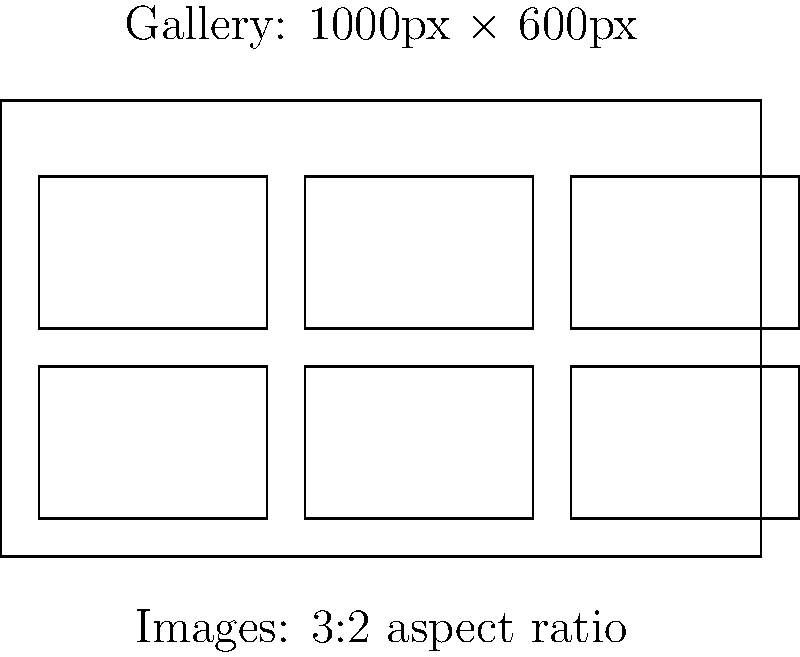As a web developer, you're tasked with creating a responsive image gallery for a client's website. The gallery container is 1000px wide and 600px tall. You need to display 6 images with a 3:2 aspect ratio, arranged in 2 rows and 3 columns, with equal spacing between images and the gallery edges. What should be the dimensions (in pixels) of each image to maximize their size while maintaining the aspect ratio and ensuring they fit within the gallery with equal spacing? To solve this problem, let's follow these steps:

1. Understand the given information:
   - Gallery size: 1000px × 600px
   - Number of images: 6 (2 rows, 3 columns)
   - Image aspect ratio: 3:2

2. Define variables:
   Let $w$ = image width, $h$ = image height, $s$ = spacing

3. Set up equations based on the gallery layout:
   - Horizontal: $3w + 4s = 1000$ (3 images, 4 spaces)
   - Vertical: $2h + 3s = 600$ (2 images, 3 spaces)

4. Express height in terms of width (3:2 aspect ratio):
   $h = \frac{2w}{3}$

5. Substitute $h$ in the vertical equation:
   $2(\frac{2w}{3}) + 3s = 600$
   $\frac{4w}{3} + 3s = 600$

6. We now have a system of two equations:
   $3w + 4s = 1000$
   $\frac{4w}{3} + 3s = 600$

7. Multiply the second equation by 3:
   $3w + 4s = 1000$
   $4w + 9s = 1800$

8. Subtract the first equation from the second:
   $w + 5s = 800$

9. Substitute this expression for $w$ in the first equation:
   $3(800 - 5s) + 4s = 1000$
   $2400 - 15s + 4s = 1000$
   $2400 - 11s = 1000$
   $-11s = -1400$
   $s = 127.27$

10. Round down the spacing to ensure it fits: $s = 127$

11. Calculate the image width:
    $w = 800 - 5s = 800 - 5(127) = 165$

12. Calculate the image height:
    $h = \frac{2w}{3} = \frac{2(165)}{3} = 110$

Therefore, the maximum image dimensions that fit the criteria are 165px × 110px.
Answer: 165px × 110px 